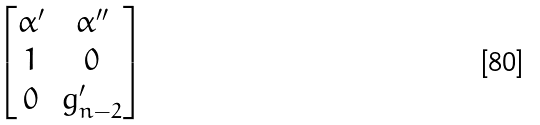Convert formula to latex. <formula><loc_0><loc_0><loc_500><loc_500>\begin{bmatrix} \alpha ^ { \prime } & \alpha ^ { \prime \prime } \\ 1 & 0 \\ 0 & g _ { n - 2 } ^ { \prime } \end{bmatrix}</formula> 